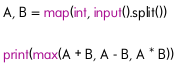Convert code to text. <code><loc_0><loc_0><loc_500><loc_500><_Python_>A, B = map(int, input().split())

print(max(A + B, A - B, A * B))</code> 